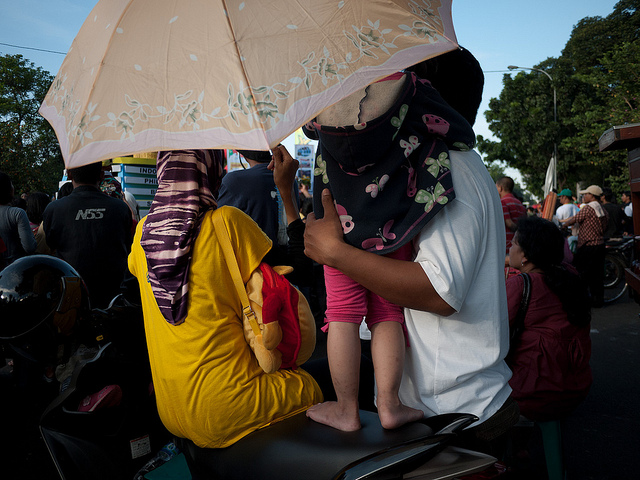Please transcribe the text information in this image. N55 INDO 